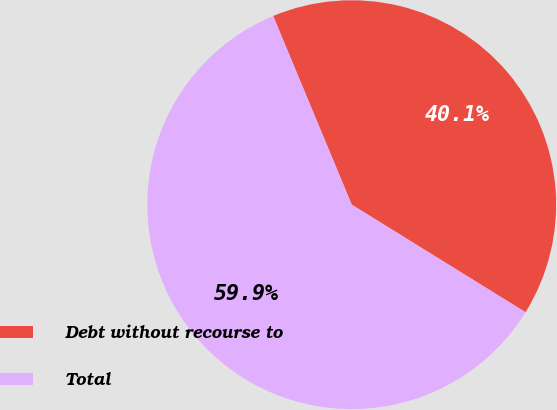<chart> <loc_0><loc_0><loc_500><loc_500><pie_chart><fcel>Debt without recourse to<fcel>Total<nl><fcel>40.1%<fcel>59.9%<nl></chart> 